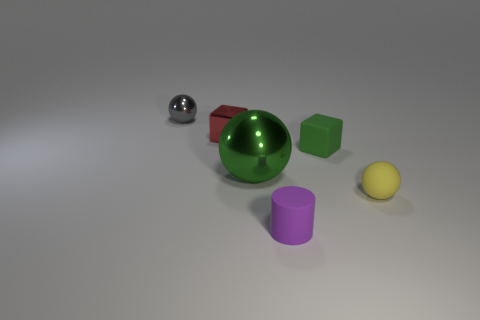What shapes are visible in the image? The image showcases a variety of geometric shapes: there are two spheres, one a reflective silver and the other a matte yellow; a green sphere with a reflective surface; a red cylinder standing on its side; and a purple cylinder that is upright. These shapes provide an interesting mix of colors and textures. 